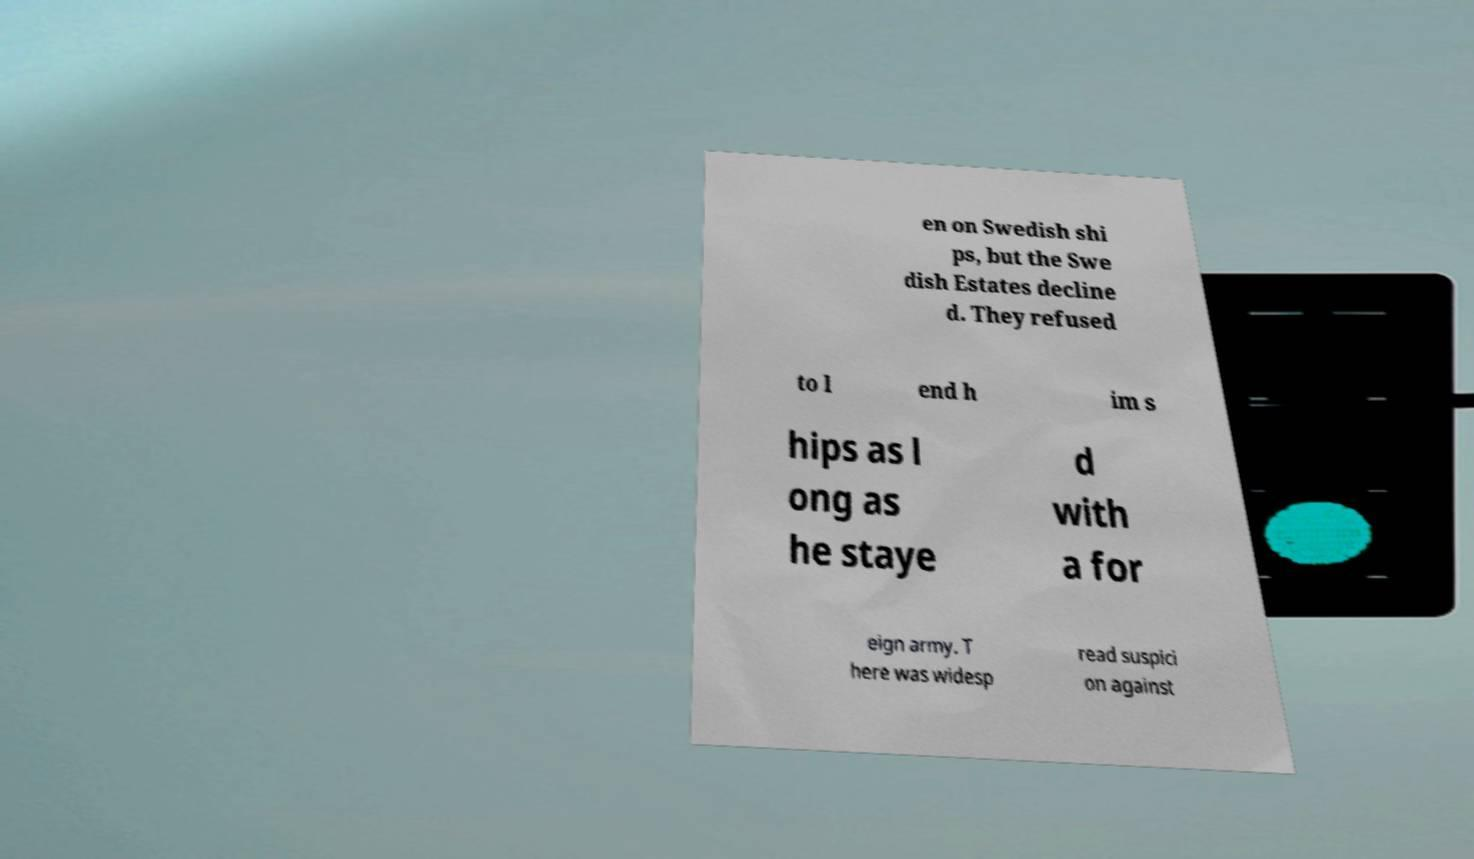Please read and relay the text visible in this image. What does it say? en on Swedish shi ps, but the Swe dish Estates decline d. They refused to l end h im s hips as l ong as he staye d with a for eign army. T here was widesp read suspici on against 